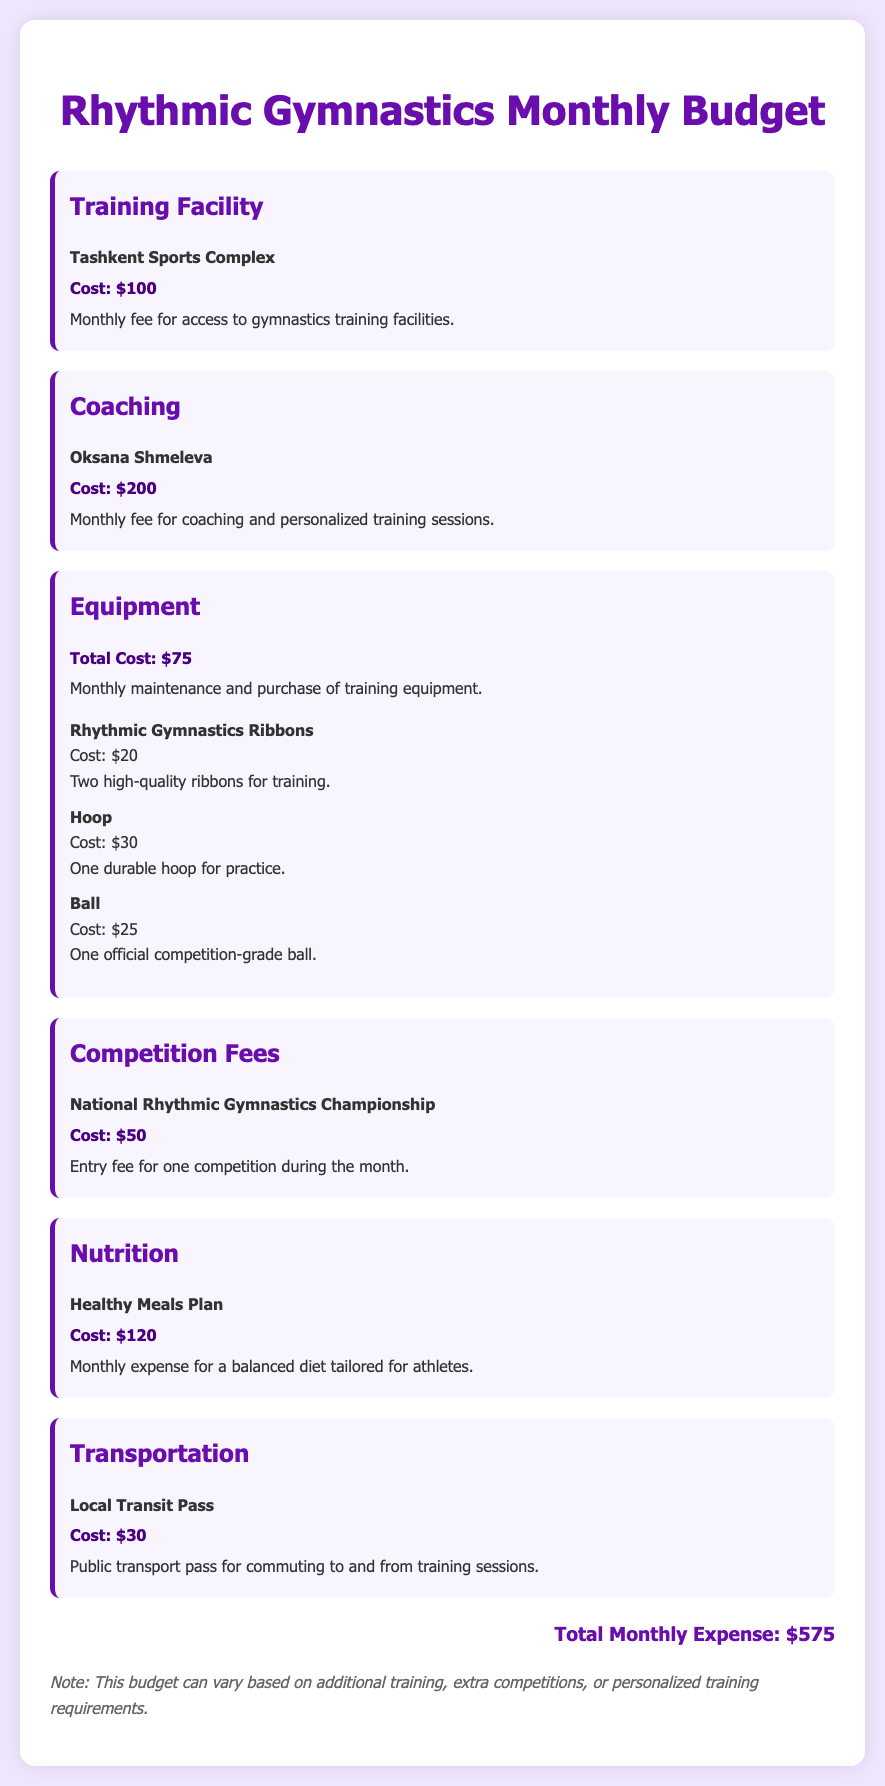What is the total monthly expense? The total monthly expense is presented at the end of the budget document, which adds up all the individual expenses.
Answer: $575 How much does coaching cost? The coaching cost is specified under the coaching budget item, which lists the fee for coaching services.
Answer: $200 What is the cost of the hoop? The cost is detailed in the equipment section, listing different items and their respective costs.
Answer: $30 What sports complex is mentioned? The training facility section names the complex where training occurs.
Answer: Tashkent Sports Complex How much is allocated for nutrition? The nutrition budget item specifies the monthly expense for meals tailored for athletes.
Answer: $120 What is the cost for competition fees? The competition fees are provided in the respective budget item, indicating the expense for a specific competition.
Answer: $50 How many rhythmic gymnastics ribbons are included in the equipment? The equipment section specifies the number of ribbons for training.
Answer: Two What is the purpose of the transportation cost? The transportation item explains the use of the expense for commuting to training sessions.
Answer: Public transport pass What is included in the monthly equipment maintenance? The equipment section lists specific items that are maintained or purchased for training.
Answer: Ribbons, Hoop, Ball 